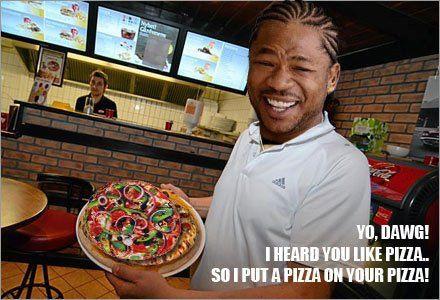What is the man eating?
Answer briefly. Pizza. What is she holding?
Answer briefly. Pizza. Did he make that pizza?
Short answer required. No. What was the person eating?
Answer briefly. Pizza. Who is the person from the meme?
Be succinct. Ice cube. Is the man looking at the camera?
Concise answer only. Yes. What are the people doing?
Quick response, please. Holding pizza. 